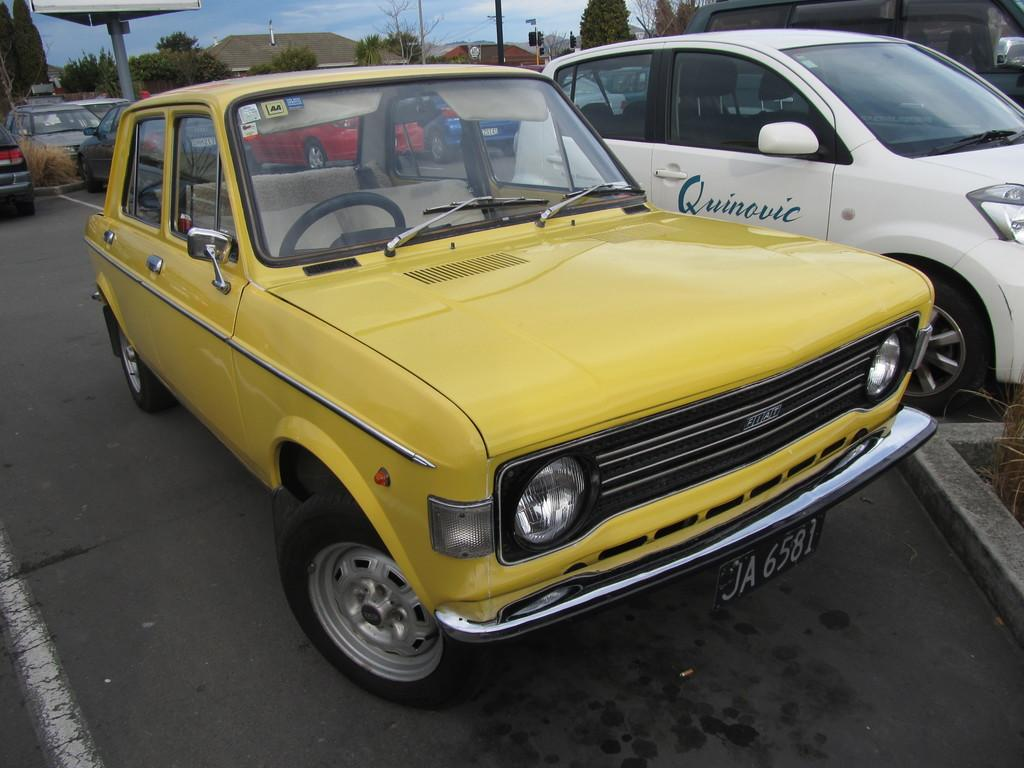What can be seen in the middle of the image? There are trees on the road in the middle of the image. What else can be seen in the background of the image? There are trees in the background of the image. What is visible at the top of the image? The sky is visible at the top of the image. What is the profit margin of the trees in the image? There is no information about profit margins in the image, as it features trees and a road. How many leaves are on the trees in the image? The image does not provide a close-up view of the trees, so it is impossible to determine the number of leaves on the trees. 